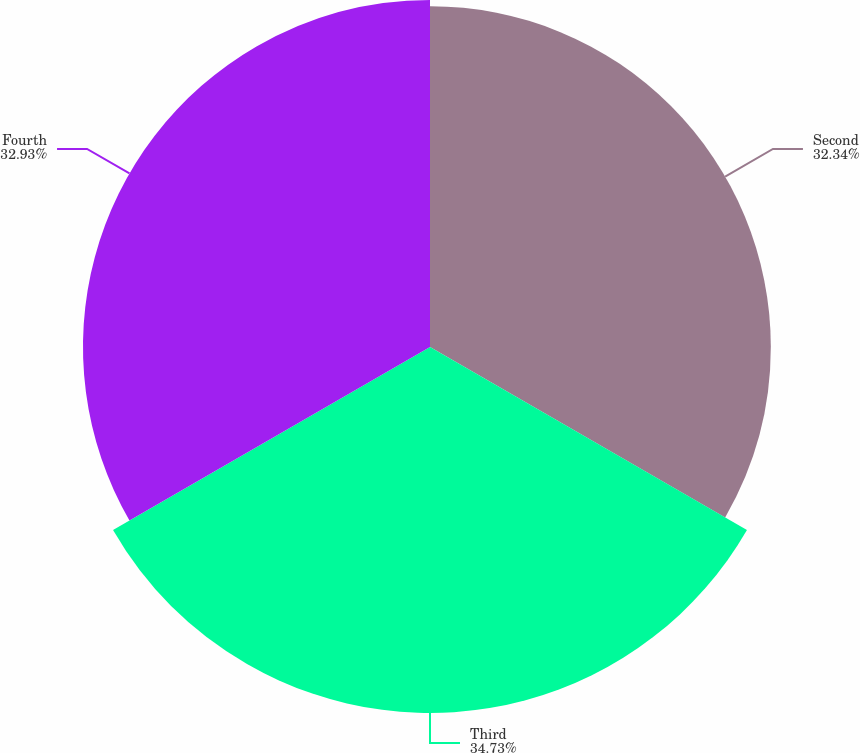Convert chart to OTSL. <chart><loc_0><loc_0><loc_500><loc_500><pie_chart><fcel>Second<fcel>Third<fcel>Fourth<nl><fcel>32.34%<fcel>34.73%<fcel>32.93%<nl></chart> 